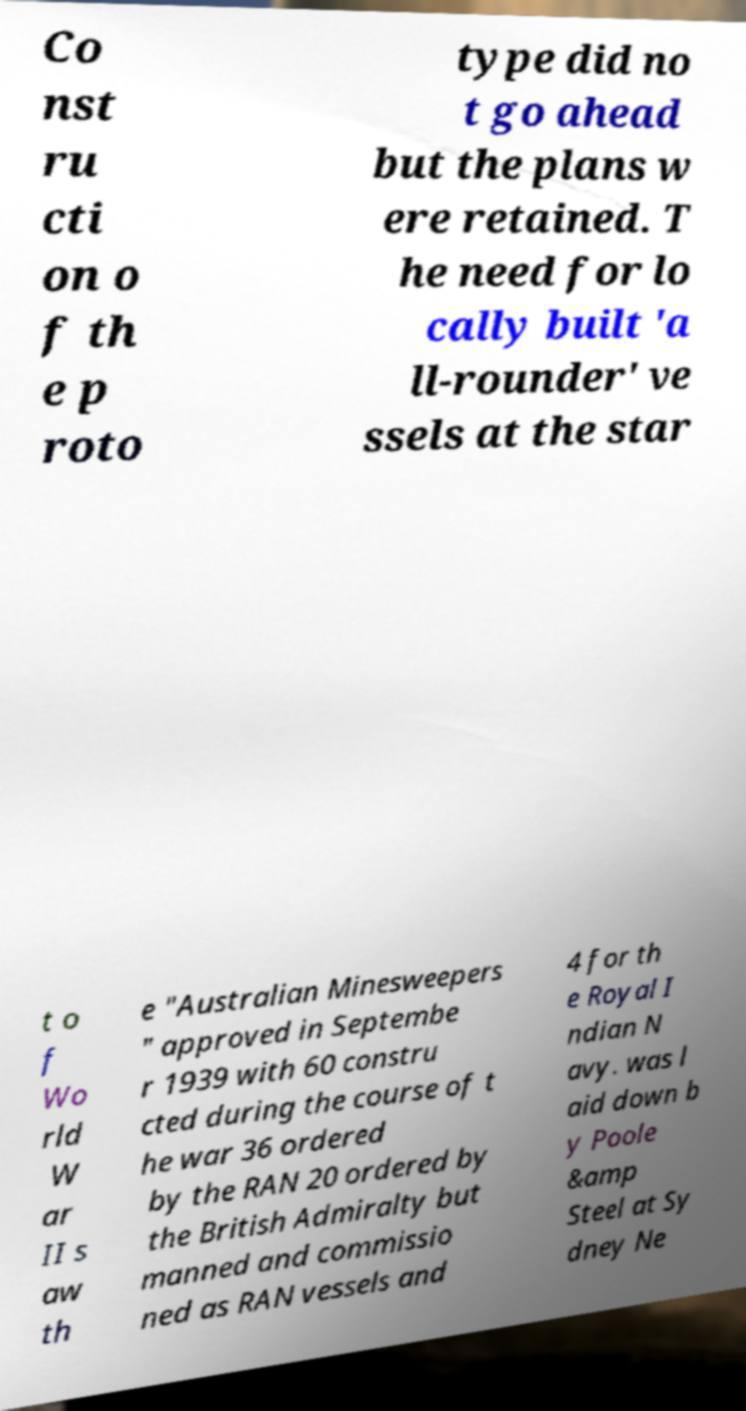Can you read and provide the text displayed in the image?This photo seems to have some interesting text. Can you extract and type it out for me? Co nst ru cti on o f th e p roto type did no t go ahead but the plans w ere retained. T he need for lo cally built 'a ll-rounder' ve ssels at the star t o f Wo rld W ar II s aw th e "Australian Minesweepers " approved in Septembe r 1939 with 60 constru cted during the course of t he war 36 ordered by the RAN 20 ordered by the British Admiralty but manned and commissio ned as RAN vessels and 4 for th e Royal I ndian N avy. was l aid down b y Poole &amp Steel at Sy dney Ne 